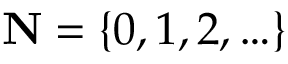<formula> <loc_0><loc_0><loc_500><loc_500>N = \{ 0 , 1 , 2 , \dots \}</formula> 